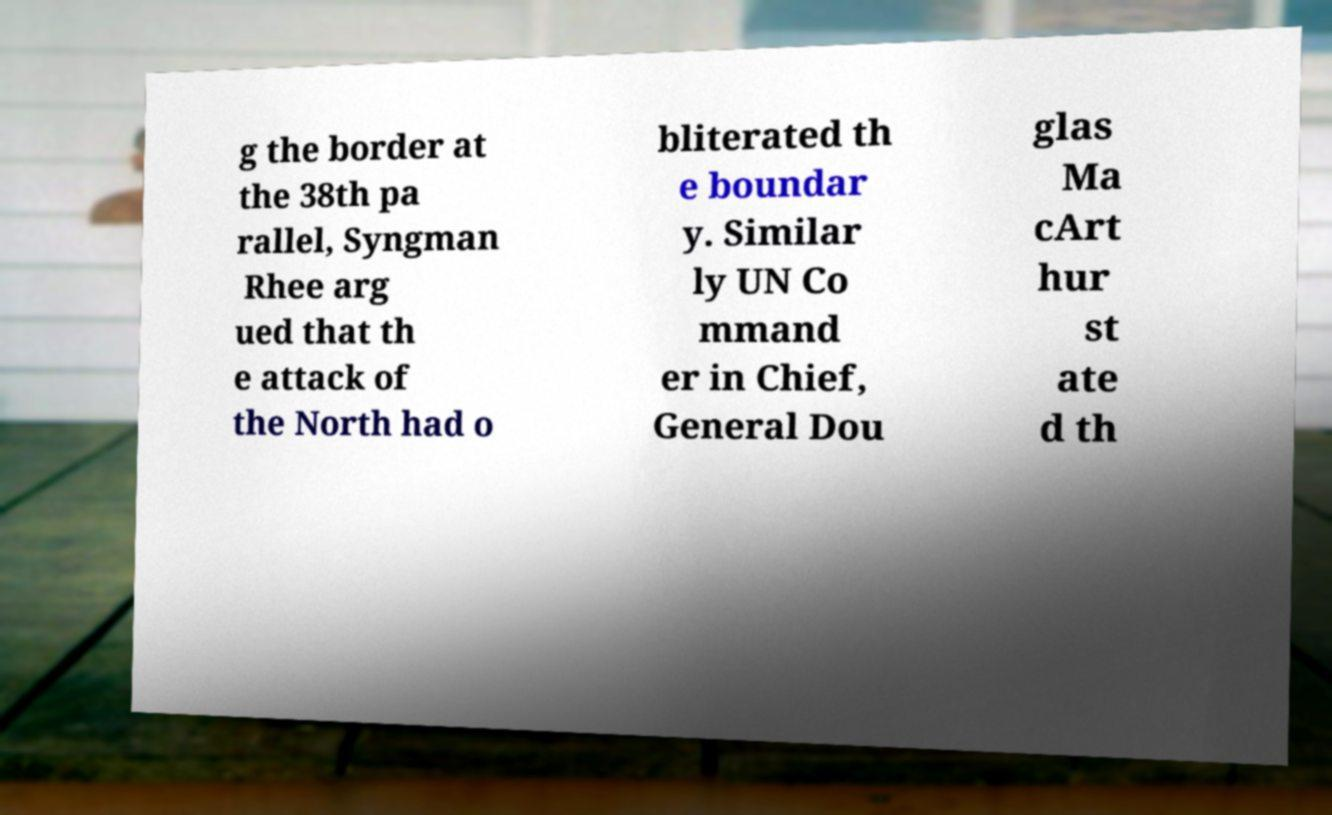Can you accurately transcribe the text from the provided image for me? g the border at the 38th pa rallel, Syngman Rhee arg ued that th e attack of the North had o bliterated th e boundar y. Similar ly UN Co mmand er in Chief, General Dou glas Ma cArt hur st ate d th 